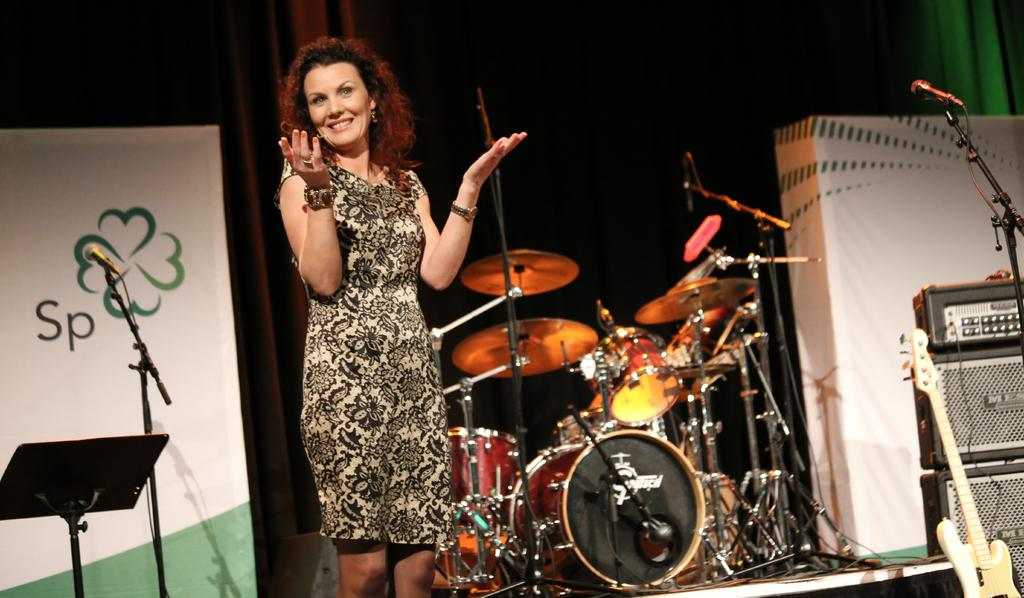What is the woman doing in the image? The woman is standing on a dais in the image. What can be seen in the background of the image? There is a band setup, speakers, and microphones in the background of the image. Can you see a kitten playing with the microphones in the image? No, there is no kitten present in the image. 